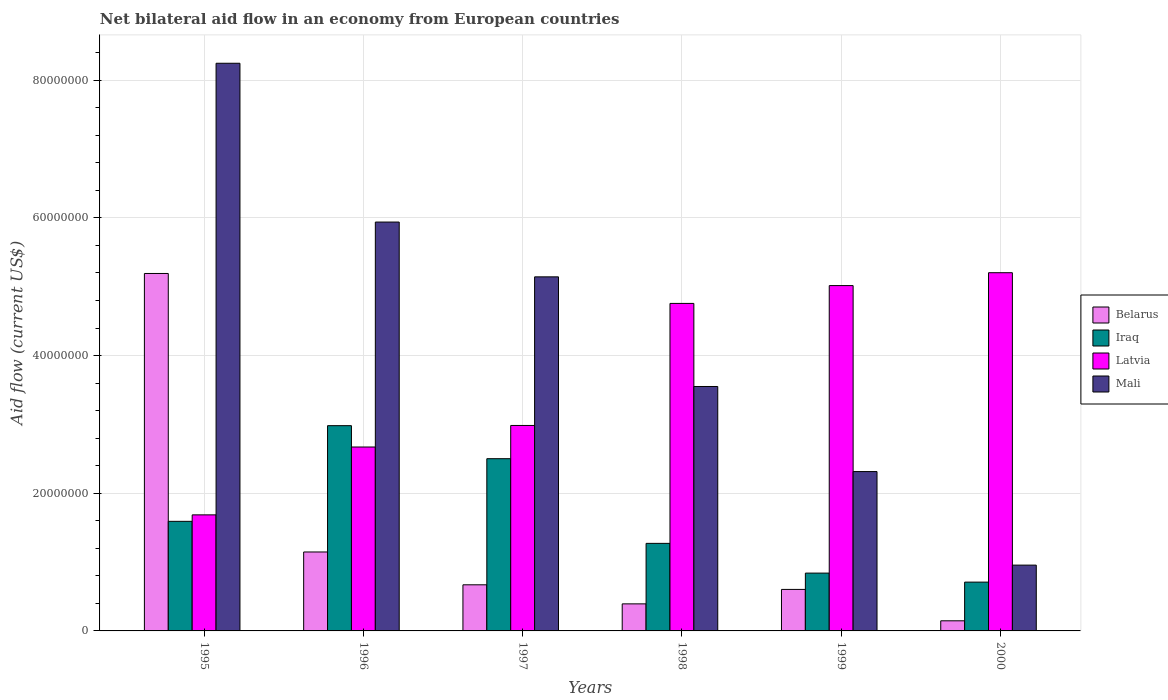How many different coloured bars are there?
Keep it short and to the point. 4. How many groups of bars are there?
Give a very brief answer. 6. Are the number of bars on each tick of the X-axis equal?
Offer a terse response. Yes. How many bars are there on the 5th tick from the right?
Your response must be concise. 4. What is the label of the 3rd group of bars from the left?
Offer a very short reply. 1997. In how many cases, is the number of bars for a given year not equal to the number of legend labels?
Offer a very short reply. 0. What is the net bilateral aid flow in Mali in 2000?
Provide a succinct answer. 9.56e+06. Across all years, what is the maximum net bilateral aid flow in Belarus?
Your response must be concise. 5.19e+07. Across all years, what is the minimum net bilateral aid flow in Mali?
Your answer should be very brief. 9.56e+06. In which year was the net bilateral aid flow in Belarus maximum?
Offer a very short reply. 1995. In which year was the net bilateral aid flow in Latvia minimum?
Ensure brevity in your answer.  1995. What is the total net bilateral aid flow in Mali in the graph?
Give a very brief answer. 2.62e+08. What is the difference between the net bilateral aid flow in Iraq in 1995 and that in 1996?
Provide a succinct answer. -1.39e+07. What is the difference between the net bilateral aid flow in Iraq in 2000 and the net bilateral aid flow in Belarus in 1995?
Your response must be concise. -4.48e+07. What is the average net bilateral aid flow in Iraq per year?
Offer a very short reply. 1.65e+07. In the year 1996, what is the difference between the net bilateral aid flow in Belarus and net bilateral aid flow in Latvia?
Provide a succinct answer. -1.52e+07. What is the ratio of the net bilateral aid flow in Latvia in 1995 to that in 1997?
Offer a terse response. 0.56. Is the net bilateral aid flow in Belarus in 1997 less than that in 1998?
Keep it short and to the point. No. What is the difference between the highest and the second highest net bilateral aid flow in Latvia?
Give a very brief answer. 1.87e+06. What is the difference between the highest and the lowest net bilateral aid flow in Mali?
Offer a terse response. 7.29e+07. In how many years, is the net bilateral aid flow in Belarus greater than the average net bilateral aid flow in Belarus taken over all years?
Provide a succinct answer. 1. Is it the case that in every year, the sum of the net bilateral aid flow in Iraq and net bilateral aid flow in Latvia is greater than the sum of net bilateral aid flow in Mali and net bilateral aid flow in Belarus?
Make the answer very short. No. What does the 2nd bar from the left in 1995 represents?
Make the answer very short. Iraq. What does the 2nd bar from the right in 1999 represents?
Offer a terse response. Latvia. Are all the bars in the graph horizontal?
Your answer should be very brief. No. Are the values on the major ticks of Y-axis written in scientific E-notation?
Your response must be concise. No. How many legend labels are there?
Make the answer very short. 4. What is the title of the graph?
Provide a succinct answer. Net bilateral aid flow in an economy from European countries. Does "Bermuda" appear as one of the legend labels in the graph?
Your answer should be compact. No. What is the label or title of the X-axis?
Offer a terse response. Years. What is the Aid flow (current US$) of Belarus in 1995?
Your answer should be very brief. 5.19e+07. What is the Aid flow (current US$) of Iraq in 1995?
Offer a very short reply. 1.59e+07. What is the Aid flow (current US$) of Latvia in 1995?
Offer a very short reply. 1.69e+07. What is the Aid flow (current US$) of Mali in 1995?
Offer a very short reply. 8.25e+07. What is the Aid flow (current US$) in Belarus in 1996?
Provide a short and direct response. 1.15e+07. What is the Aid flow (current US$) of Iraq in 1996?
Give a very brief answer. 2.98e+07. What is the Aid flow (current US$) in Latvia in 1996?
Provide a succinct answer. 2.67e+07. What is the Aid flow (current US$) in Mali in 1996?
Ensure brevity in your answer.  5.94e+07. What is the Aid flow (current US$) in Belarus in 1997?
Keep it short and to the point. 6.70e+06. What is the Aid flow (current US$) in Iraq in 1997?
Your answer should be very brief. 2.50e+07. What is the Aid flow (current US$) in Latvia in 1997?
Your response must be concise. 2.98e+07. What is the Aid flow (current US$) of Mali in 1997?
Ensure brevity in your answer.  5.14e+07. What is the Aid flow (current US$) in Belarus in 1998?
Ensure brevity in your answer.  3.93e+06. What is the Aid flow (current US$) of Iraq in 1998?
Offer a terse response. 1.27e+07. What is the Aid flow (current US$) in Latvia in 1998?
Offer a terse response. 4.76e+07. What is the Aid flow (current US$) in Mali in 1998?
Ensure brevity in your answer.  3.55e+07. What is the Aid flow (current US$) in Belarus in 1999?
Make the answer very short. 6.03e+06. What is the Aid flow (current US$) of Iraq in 1999?
Ensure brevity in your answer.  8.40e+06. What is the Aid flow (current US$) in Latvia in 1999?
Make the answer very short. 5.02e+07. What is the Aid flow (current US$) of Mali in 1999?
Your answer should be compact. 2.32e+07. What is the Aid flow (current US$) of Belarus in 2000?
Make the answer very short. 1.47e+06. What is the Aid flow (current US$) of Iraq in 2000?
Offer a very short reply. 7.09e+06. What is the Aid flow (current US$) of Latvia in 2000?
Make the answer very short. 5.20e+07. What is the Aid flow (current US$) in Mali in 2000?
Offer a very short reply. 9.56e+06. Across all years, what is the maximum Aid flow (current US$) of Belarus?
Provide a succinct answer. 5.19e+07. Across all years, what is the maximum Aid flow (current US$) of Iraq?
Offer a very short reply. 2.98e+07. Across all years, what is the maximum Aid flow (current US$) of Latvia?
Your answer should be very brief. 5.20e+07. Across all years, what is the maximum Aid flow (current US$) in Mali?
Provide a succinct answer. 8.25e+07. Across all years, what is the minimum Aid flow (current US$) of Belarus?
Make the answer very short. 1.47e+06. Across all years, what is the minimum Aid flow (current US$) of Iraq?
Ensure brevity in your answer.  7.09e+06. Across all years, what is the minimum Aid flow (current US$) in Latvia?
Offer a terse response. 1.69e+07. Across all years, what is the minimum Aid flow (current US$) in Mali?
Offer a very short reply. 9.56e+06. What is the total Aid flow (current US$) in Belarus in the graph?
Your answer should be compact. 8.15e+07. What is the total Aid flow (current US$) of Iraq in the graph?
Give a very brief answer. 9.90e+07. What is the total Aid flow (current US$) in Latvia in the graph?
Keep it short and to the point. 2.23e+08. What is the total Aid flow (current US$) in Mali in the graph?
Provide a short and direct response. 2.62e+08. What is the difference between the Aid flow (current US$) of Belarus in 1995 and that in 1996?
Your answer should be very brief. 4.05e+07. What is the difference between the Aid flow (current US$) in Iraq in 1995 and that in 1996?
Offer a very short reply. -1.39e+07. What is the difference between the Aid flow (current US$) in Latvia in 1995 and that in 1996?
Your response must be concise. -9.86e+06. What is the difference between the Aid flow (current US$) of Mali in 1995 and that in 1996?
Provide a succinct answer. 2.31e+07. What is the difference between the Aid flow (current US$) of Belarus in 1995 and that in 1997?
Your answer should be very brief. 4.52e+07. What is the difference between the Aid flow (current US$) of Iraq in 1995 and that in 1997?
Offer a terse response. -9.10e+06. What is the difference between the Aid flow (current US$) of Latvia in 1995 and that in 1997?
Your response must be concise. -1.30e+07. What is the difference between the Aid flow (current US$) of Mali in 1995 and that in 1997?
Make the answer very short. 3.10e+07. What is the difference between the Aid flow (current US$) in Belarus in 1995 and that in 1998?
Your answer should be compact. 4.80e+07. What is the difference between the Aid flow (current US$) of Iraq in 1995 and that in 1998?
Offer a terse response. 3.20e+06. What is the difference between the Aid flow (current US$) of Latvia in 1995 and that in 1998?
Provide a short and direct response. -3.07e+07. What is the difference between the Aid flow (current US$) of Mali in 1995 and that in 1998?
Ensure brevity in your answer.  4.70e+07. What is the difference between the Aid flow (current US$) in Belarus in 1995 and that in 1999?
Your answer should be compact. 4.59e+07. What is the difference between the Aid flow (current US$) in Iraq in 1995 and that in 1999?
Ensure brevity in your answer.  7.52e+06. What is the difference between the Aid flow (current US$) in Latvia in 1995 and that in 1999?
Ensure brevity in your answer.  -3.33e+07. What is the difference between the Aid flow (current US$) in Mali in 1995 and that in 1999?
Give a very brief answer. 5.93e+07. What is the difference between the Aid flow (current US$) in Belarus in 1995 and that in 2000?
Provide a succinct answer. 5.05e+07. What is the difference between the Aid flow (current US$) in Iraq in 1995 and that in 2000?
Keep it short and to the point. 8.83e+06. What is the difference between the Aid flow (current US$) of Latvia in 1995 and that in 2000?
Your answer should be compact. -3.52e+07. What is the difference between the Aid flow (current US$) in Mali in 1995 and that in 2000?
Ensure brevity in your answer.  7.29e+07. What is the difference between the Aid flow (current US$) in Belarus in 1996 and that in 1997?
Provide a short and direct response. 4.77e+06. What is the difference between the Aid flow (current US$) of Iraq in 1996 and that in 1997?
Make the answer very short. 4.80e+06. What is the difference between the Aid flow (current US$) of Latvia in 1996 and that in 1997?
Ensure brevity in your answer.  -3.13e+06. What is the difference between the Aid flow (current US$) in Mali in 1996 and that in 1997?
Ensure brevity in your answer.  7.96e+06. What is the difference between the Aid flow (current US$) in Belarus in 1996 and that in 1998?
Offer a terse response. 7.54e+06. What is the difference between the Aid flow (current US$) of Iraq in 1996 and that in 1998?
Your answer should be compact. 1.71e+07. What is the difference between the Aid flow (current US$) in Latvia in 1996 and that in 1998?
Your response must be concise. -2.09e+07. What is the difference between the Aid flow (current US$) of Mali in 1996 and that in 1998?
Keep it short and to the point. 2.39e+07. What is the difference between the Aid flow (current US$) in Belarus in 1996 and that in 1999?
Make the answer very short. 5.44e+06. What is the difference between the Aid flow (current US$) in Iraq in 1996 and that in 1999?
Keep it short and to the point. 2.14e+07. What is the difference between the Aid flow (current US$) of Latvia in 1996 and that in 1999?
Ensure brevity in your answer.  -2.34e+07. What is the difference between the Aid flow (current US$) in Mali in 1996 and that in 1999?
Offer a terse response. 3.62e+07. What is the difference between the Aid flow (current US$) in Iraq in 1996 and that in 2000?
Keep it short and to the point. 2.27e+07. What is the difference between the Aid flow (current US$) in Latvia in 1996 and that in 2000?
Offer a very short reply. -2.53e+07. What is the difference between the Aid flow (current US$) in Mali in 1996 and that in 2000?
Your answer should be compact. 4.98e+07. What is the difference between the Aid flow (current US$) of Belarus in 1997 and that in 1998?
Your answer should be compact. 2.77e+06. What is the difference between the Aid flow (current US$) in Iraq in 1997 and that in 1998?
Give a very brief answer. 1.23e+07. What is the difference between the Aid flow (current US$) in Latvia in 1997 and that in 1998?
Your answer should be compact. -1.77e+07. What is the difference between the Aid flow (current US$) in Mali in 1997 and that in 1998?
Keep it short and to the point. 1.59e+07. What is the difference between the Aid flow (current US$) in Belarus in 1997 and that in 1999?
Offer a very short reply. 6.70e+05. What is the difference between the Aid flow (current US$) of Iraq in 1997 and that in 1999?
Offer a terse response. 1.66e+07. What is the difference between the Aid flow (current US$) in Latvia in 1997 and that in 1999?
Provide a short and direct response. -2.03e+07. What is the difference between the Aid flow (current US$) in Mali in 1997 and that in 1999?
Offer a terse response. 2.83e+07. What is the difference between the Aid flow (current US$) of Belarus in 1997 and that in 2000?
Give a very brief answer. 5.23e+06. What is the difference between the Aid flow (current US$) in Iraq in 1997 and that in 2000?
Keep it short and to the point. 1.79e+07. What is the difference between the Aid flow (current US$) of Latvia in 1997 and that in 2000?
Give a very brief answer. -2.22e+07. What is the difference between the Aid flow (current US$) in Mali in 1997 and that in 2000?
Give a very brief answer. 4.19e+07. What is the difference between the Aid flow (current US$) in Belarus in 1998 and that in 1999?
Make the answer very short. -2.10e+06. What is the difference between the Aid flow (current US$) of Iraq in 1998 and that in 1999?
Offer a terse response. 4.32e+06. What is the difference between the Aid flow (current US$) of Latvia in 1998 and that in 1999?
Give a very brief answer. -2.59e+06. What is the difference between the Aid flow (current US$) of Mali in 1998 and that in 1999?
Provide a succinct answer. 1.24e+07. What is the difference between the Aid flow (current US$) in Belarus in 1998 and that in 2000?
Offer a very short reply. 2.46e+06. What is the difference between the Aid flow (current US$) in Iraq in 1998 and that in 2000?
Your answer should be compact. 5.63e+06. What is the difference between the Aid flow (current US$) in Latvia in 1998 and that in 2000?
Provide a succinct answer. -4.46e+06. What is the difference between the Aid flow (current US$) of Mali in 1998 and that in 2000?
Ensure brevity in your answer.  2.60e+07. What is the difference between the Aid flow (current US$) of Belarus in 1999 and that in 2000?
Your answer should be very brief. 4.56e+06. What is the difference between the Aid flow (current US$) of Iraq in 1999 and that in 2000?
Your response must be concise. 1.31e+06. What is the difference between the Aid flow (current US$) in Latvia in 1999 and that in 2000?
Keep it short and to the point. -1.87e+06. What is the difference between the Aid flow (current US$) of Mali in 1999 and that in 2000?
Ensure brevity in your answer.  1.36e+07. What is the difference between the Aid flow (current US$) of Belarus in 1995 and the Aid flow (current US$) of Iraq in 1996?
Provide a succinct answer. 2.21e+07. What is the difference between the Aid flow (current US$) in Belarus in 1995 and the Aid flow (current US$) in Latvia in 1996?
Ensure brevity in your answer.  2.52e+07. What is the difference between the Aid flow (current US$) in Belarus in 1995 and the Aid flow (current US$) in Mali in 1996?
Give a very brief answer. -7.47e+06. What is the difference between the Aid flow (current US$) in Iraq in 1995 and the Aid flow (current US$) in Latvia in 1996?
Provide a short and direct response. -1.08e+07. What is the difference between the Aid flow (current US$) of Iraq in 1995 and the Aid flow (current US$) of Mali in 1996?
Give a very brief answer. -4.35e+07. What is the difference between the Aid flow (current US$) in Latvia in 1995 and the Aid flow (current US$) in Mali in 1996?
Offer a very short reply. -4.25e+07. What is the difference between the Aid flow (current US$) in Belarus in 1995 and the Aid flow (current US$) in Iraq in 1997?
Provide a succinct answer. 2.69e+07. What is the difference between the Aid flow (current US$) of Belarus in 1995 and the Aid flow (current US$) of Latvia in 1997?
Offer a very short reply. 2.21e+07. What is the difference between the Aid flow (current US$) in Belarus in 1995 and the Aid flow (current US$) in Mali in 1997?
Offer a very short reply. 4.90e+05. What is the difference between the Aid flow (current US$) in Iraq in 1995 and the Aid flow (current US$) in Latvia in 1997?
Provide a succinct answer. -1.39e+07. What is the difference between the Aid flow (current US$) in Iraq in 1995 and the Aid flow (current US$) in Mali in 1997?
Provide a succinct answer. -3.55e+07. What is the difference between the Aid flow (current US$) of Latvia in 1995 and the Aid flow (current US$) of Mali in 1997?
Keep it short and to the point. -3.46e+07. What is the difference between the Aid flow (current US$) of Belarus in 1995 and the Aid flow (current US$) of Iraq in 1998?
Ensure brevity in your answer.  3.92e+07. What is the difference between the Aid flow (current US$) in Belarus in 1995 and the Aid flow (current US$) in Latvia in 1998?
Keep it short and to the point. 4.35e+06. What is the difference between the Aid flow (current US$) in Belarus in 1995 and the Aid flow (current US$) in Mali in 1998?
Make the answer very short. 1.64e+07. What is the difference between the Aid flow (current US$) in Iraq in 1995 and the Aid flow (current US$) in Latvia in 1998?
Provide a short and direct response. -3.17e+07. What is the difference between the Aid flow (current US$) of Iraq in 1995 and the Aid flow (current US$) of Mali in 1998?
Your answer should be compact. -1.96e+07. What is the difference between the Aid flow (current US$) in Latvia in 1995 and the Aid flow (current US$) in Mali in 1998?
Your answer should be very brief. -1.86e+07. What is the difference between the Aid flow (current US$) of Belarus in 1995 and the Aid flow (current US$) of Iraq in 1999?
Your response must be concise. 4.35e+07. What is the difference between the Aid flow (current US$) in Belarus in 1995 and the Aid flow (current US$) in Latvia in 1999?
Your answer should be compact. 1.76e+06. What is the difference between the Aid flow (current US$) of Belarus in 1995 and the Aid flow (current US$) of Mali in 1999?
Your answer should be compact. 2.88e+07. What is the difference between the Aid flow (current US$) of Iraq in 1995 and the Aid flow (current US$) of Latvia in 1999?
Your response must be concise. -3.42e+07. What is the difference between the Aid flow (current US$) in Iraq in 1995 and the Aid flow (current US$) in Mali in 1999?
Your answer should be very brief. -7.23e+06. What is the difference between the Aid flow (current US$) in Latvia in 1995 and the Aid flow (current US$) in Mali in 1999?
Offer a very short reply. -6.29e+06. What is the difference between the Aid flow (current US$) in Belarus in 1995 and the Aid flow (current US$) in Iraq in 2000?
Keep it short and to the point. 4.48e+07. What is the difference between the Aid flow (current US$) of Belarus in 1995 and the Aid flow (current US$) of Latvia in 2000?
Provide a succinct answer. -1.10e+05. What is the difference between the Aid flow (current US$) of Belarus in 1995 and the Aid flow (current US$) of Mali in 2000?
Make the answer very short. 4.24e+07. What is the difference between the Aid flow (current US$) of Iraq in 1995 and the Aid flow (current US$) of Latvia in 2000?
Provide a succinct answer. -3.61e+07. What is the difference between the Aid flow (current US$) of Iraq in 1995 and the Aid flow (current US$) of Mali in 2000?
Provide a short and direct response. 6.36e+06. What is the difference between the Aid flow (current US$) of Latvia in 1995 and the Aid flow (current US$) of Mali in 2000?
Provide a succinct answer. 7.30e+06. What is the difference between the Aid flow (current US$) in Belarus in 1996 and the Aid flow (current US$) in Iraq in 1997?
Ensure brevity in your answer.  -1.36e+07. What is the difference between the Aid flow (current US$) of Belarus in 1996 and the Aid flow (current US$) of Latvia in 1997?
Your response must be concise. -1.84e+07. What is the difference between the Aid flow (current US$) of Belarus in 1996 and the Aid flow (current US$) of Mali in 1997?
Give a very brief answer. -4.00e+07. What is the difference between the Aid flow (current US$) of Iraq in 1996 and the Aid flow (current US$) of Latvia in 1997?
Keep it short and to the point. -3.00e+04. What is the difference between the Aid flow (current US$) in Iraq in 1996 and the Aid flow (current US$) in Mali in 1997?
Your response must be concise. -2.16e+07. What is the difference between the Aid flow (current US$) in Latvia in 1996 and the Aid flow (current US$) in Mali in 1997?
Make the answer very short. -2.47e+07. What is the difference between the Aid flow (current US$) in Belarus in 1996 and the Aid flow (current US$) in Iraq in 1998?
Offer a terse response. -1.25e+06. What is the difference between the Aid flow (current US$) in Belarus in 1996 and the Aid flow (current US$) in Latvia in 1998?
Make the answer very short. -3.61e+07. What is the difference between the Aid flow (current US$) of Belarus in 1996 and the Aid flow (current US$) of Mali in 1998?
Ensure brevity in your answer.  -2.40e+07. What is the difference between the Aid flow (current US$) in Iraq in 1996 and the Aid flow (current US$) in Latvia in 1998?
Your response must be concise. -1.78e+07. What is the difference between the Aid flow (current US$) in Iraq in 1996 and the Aid flow (current US$) in Mali in 1998?
Your answer should be compact. -5.69e+06. What is the difference between the Aid flow (current US$) of Latvia in 1996 and the Aid flow (current US$) of Mali in 1998?
Provide a succinct answer. -8.79e+06. What is the difference between the Aid flow (current US$) of Belarus in 1996 and the Aid flow (current US$) of Iraq in 1999?
Ensure brevity in your answer.  3.07e+06. What is the difference between the Aid flow (current US$) of Belarus in 1996 and the Aid flow (current US$) of Latvia in 1999?
Offer a very short reply. -3.87e+07. What is the difference between the Aid flow (current US$) of Belarus in 1996 and the Aid flow (current US$) of Mali in 1999?
Your answer should be very brief. -1.17e+07. What is the difference between the Aid flow (current US$) of Iraq in 1996 and the Aid flow (current US$) of Latvia in 1999?
Ensure brevity in your answer.  -2.04e+07. What is the difference between the Aid flow (current US$) in Iraq in 1996 and the Aid flow (current US$) in Mali in 1999?
Provide a short and direct response. 6.67e+06. What is the difference between the Aid flow (current US$) in Latvia in 1996 and the Aid flow (current US$) in Mali in 1999?
Your answer should be compact. 3.57e+06. What is the difference between the Aid flow (current US$) in Belarus in 1996 and the Aid flow (current US$) in Iraq in 2000?
Your response must be concise. 4.38e+06. What is the difference between the Aid flow (current US$) in Belarus in 1996 and the Aid flow (current US$) in Latvia in 2000?
Provide a short and direct response. -4.06e+07. What is the difference between the Aid flow (current US$) of Belarus in 1996 and the Aid flow (current US$) of Mali in 2000?
Offer a terse response. 1.91e+06. What is the difference between the Aid flow (current US$) of Iraq in 1996 and the Aid flow (current US$) of Latvia in 2000?
Provide a succinct answer. -2.22e+07. What is the difference between the Aid flow (current US$) in Iraq in 1996 and the Aid flow (current US$) in Mali in 2000?
Your answer should be very brief. 2.03e+07. What is the difference between the Aid flow (current US$) of Latvia in 1996 and the Aid flow (current US$) of Mali in 2000?
Make the answer very short. 1.72e+07. What is the difference between the Aid flow (current US$) of Belarus in 1997 and the Aid flow (current US$) of Iraq in 1998?
Make the answer very short. -6.02e+06. What is the difference between the Aid flow (current US$) of Belarus in 1997 and the Aid flow (current US$) of Latvia in 1998?
Give a very brief answer. -4.09e+07. What is the difference between the Aid flow (current US$) in Belarus in 1997 and the Aid flow (current US$) in Mali in 1998?
Offer a terse response. -2.88e+07. What is the difference between the Aid flow (current US$) of Iraq in 1997 and the Aid flow (current US$) of Latvia in 1998?
Make the answer very short. -2.26e+07. What is the difference between the Aid flow (current US$) in Iraq in 1997 and the Aid flow (current US$) in Mali in 1998?
Make the answer very short. -1.05e+07. What is the difference between the Aid flow (current US$) in Latvia in 1997 and the Aid flow (current US$) in Mali in 1998?
Your response must be concise. -5.66e+06. What is the difference between the Aid flow (current US$) in Belarus in 1997 and the Aid flow (current US$) in Iraq in 1999?
Provide a succinct answer. -1.70e+06. What is the difference between the Aid flow (current US$) in Belarus in 1997 and the Aid flow (current US$) in Latvia in 1999?
Your answer should be very brief. -4.35e+07. What is the difference between the Aid flow (current US$) of Belarus in 1997 and the Aid flow (current US$) of Mali in 1999?
Provide a short and direct response. -1.64e+07. What is the difference between the Aid flow (current US$) in Iraq in 1997 and the Aid flow (current US$) in Latvia in 1999?
Your response must be concise. -2.52e+07. What is the difference between the Aid flow (current US$) of Iraq in 1997 and the Aid flow (current US$) of Mali in 1999?
Your response must be concise. 1.87e+06. What is the difference between the Aid flow (current US$) in Latvia in 1997 and the Aid flow (current US$) in Mali in 1999?
Offer a very short reply. 6.70e+06. What is the difference between the Aid flow (current US$) of Belarus in 1997 and the Aid flow (current US$) of Iraq in 2000?
Provide a short and direct response. -3.90e+05. What is the difference between the Aid flow (current US$) in Belarus in 1997 and the Aid flow (current US$) in Latvia in 2000?
Your response must be concise. -4.53e+07. What is the difference between the Aid flow (current US$) of Belarus in 1997 and the Aid flow (current US$) of Mali in 2000?
Your answer should be compact. -2.86e+06. What is the difference between the Aid flow (current US$) of Iraq in 1997 and the Aid flow (current US$) of Latvia in 2000?
Give a very brief answer. -2.70e+07. What is the difference between the Aid flow (current US$) in Iraq in 1997 and the Aid flow (current US$) in Mali in 2000?
Provide a succinct answer. 1.55e+07. What is the difference between the Aid flow (current US$) of Latvia in 1997 and the Aid flow (current US$) of Mali in 2000?
Provide a succinct answer. 2.03e+07. What is the difference between the Aid flow (current US$) of Belarus in 1998 and the Aid flow (current US$) of Iraq in 1999?
Ensure brevity in your answer.  -4.47e+06. What is the difference between the Aid flow (current US$) of Belarus in 1998 and the Aid flow (current US$) of Latvia in 1999?
Ensure brevity in your answer.  -4.62e+07. What is the difference between the Aid flow (current US$) of Belarus in 1998 and the Aid flow (current US$) of Mali in 1999?
Make the answer very short. -1.92e+07. What is the difference between the Aid flow (current US$) of Iraq in 1998 and the Aid flow (current US$) of Latvia in 1999?
Give a very brief answer. -3.74e+07. What is the difference between the Aid flow (current US$) in Iraq in 1998 and the Aid flow (current US$) in Mali in 1999?
Keep it short and to the point. -1.04e+07. What is the difference between the Aid flow (current US$) in Latvia in 1998 and the Aid flow (current US$) in Mali in 1999?
Keep it short and to the point. 2.44e+07. What is the difference between the Aid flow (current US$) of Belarus in 1998 and the Aid flow (current US$) of Iraq in 2000?
Ensure brevity in your answer.  -3.16e+06. What is the difference between the Aid flow (current US$) of Belarus in 1998 and the Aid flow (current US$) of Latvia in 2000?
Your response must be concise. -4.81e+07. What is the difference between the Aid flow (current US$) of Belarus in 1998 and the Aid flow (current US$) of Mali in 2000?
Provide a short and direct response. -5.63e+06. What is the difference between the Aid flow (current US$) in Iraq in 1998 and the Aid flow (current US$) in Latvia in 2000?
Your response must be concise. -3.93e+07. What is the difference between the Aid flow (current US$) of Iraq in 1998 and the Aid flow (current US$) of Mali in 2000?
Give a very brief answer. 3.16e+06. What is the difference between the Aid flow (current US$) in Latvia in 1998 and the Aid flow (current US$) in Mali in 2000?
Give a very brief answer. 3.80e+07. What is the difference between the Aid flow (current US$) of Belarus in 1999 and the Aid flow (current US$) of Iraq in 2000?
Make the answer very short. -1.06e+06. What is the difference between the Aid flow (current US$) of Belarus in 1999 and the Aid flow (current US$) of Latvia in 2000?
Provide a short and direct response. -4.60e+07. What is the difference between the Aid flow (current US$) in Belarus in 1999 and the Aid flow (current US$) in Mali in 2000?
Give a very brief answer. -3.53e+06. What is the difference between the Aid flow (current US$) in Iraq in 1999 and the Aid flow (current US$) in Latvia in 2000?
Make the answer very short. -4.36e+07. What is the difference between the Aid flow (current US$) of Iraq in 1999 and the Aid flow (current US$) of Mali in 2000?
Offer a very short reply. -1.16e+06. What is the difference between the Aid flow (current US$) of Latvia in 1999 and the Aid flow (current US$) of Mali in 2000?
Ensure brevity in your answer.  4.06e+07. What is the average Aid flow (current US$) of Belarus per year?
Ensure brevity in your answer.  1.36e+07. What is the average Aid flow (current US$) in Iraq per year?
Keep it short and to the point. 1.65e+07. What is the average Aid flow (current US$) of Latvia per year?
Give a very brief answer. 3.72e+07. What is the average Aid flow (current US$) of Mali per year?
Offer a very short reply. 4.36e+07. In the year 1995, what is the difference between the Aid flow (current US$) of Belarus and Aid flow (current US$) of Iraq?
Give a very brief answer. 3.60e+07. In the year 1995, what is the difference between the Aid flow (current US$) in Belarus and Aid flow (current US$) in Latvia?
Make the answer very short. 3.51e+07. In the year 1995, what is the difference between the Aid flow (current US$) in Belarus and Aid flow (current US$) in Mali?
Make the answer very short. -3.05e+07. In the year 1995, what is the difference between the Aid flow (current US$) in Iraq and Aid flow (current US$) in Latvia?
Give a very brief answer. -9.40e+05. In the year 1995, what is the difference between the Aid flow (current US$) in Iraq and Aid flow (current US$) in Mali?
Your answer should be very brief. -6.66e+07. In the year 1995, what is the difference between the Aid flow (current US$) of Latvia and Aid flow (current US$) of Mali?
Provide a succinct answer. -6.56e+07. In the year 1996, what is the difference between the Aid flow (current US$) of Belarus and Aid flow (current US$) of Iraq?
Make the answer very short. -1.84e+07. In the year 1996, what is the difference between the Aid flow (current US$) in Belarus and Aid flow (current US$) in Latvia?
Offer a very short reply. -1.52e+07. In the year 1996, what is the difference between the Aid flow (current US$) of Belarus and Aid flow (current US$) of Mali?
Give a very brief answer. -4.79e+07. In the year 1996, what is the difference between the Aid flow (current US$) of Iraq and Aid flow (current US$) of Latvia?
Provide a short and direct response. 3.10e+06. In the year 1996, what is the difference between the Aid flow (current US$) of Iraq and Aid flow (current US$) of Mali?
Your response must be concise. -2.96e+07. In the year 1996, what is the difference between the Aid flow (current US$) in Latvia and Aid flow (current US$) in Mali?
Make the answer very short. -3.27e+07. In the year 1997, what is the difference between the Aid flow (current US$) in Belarus and Aid flow (current US$) in Iraq?
Ensure brevity in your answer.  -1.83e+07. In the year 1997, what is the difference between the Aid flow (current US$) of Belarus and Aid flow (current US$) of Latvia?
Offer a very short reply. -2.32e+07. In the year 1997, what is the difference between the Aid flow (current US$) in Belarus and Aid flow (current US$) in Mali?
Your answer should be very brief. -4.47e+07. In the year 1997, what is the difference between the Aid flow (current US$) of Iraq and Aid flow (current US$) of Latvia?
Your answer should be compact. -4.83e+06. In the year 1997, what is the difference between the Aid flow (current US$) of Iraq and Aid flow (current US$) of Mali?
Provide a short and direct response. -2.64e+07. In the year 1997, what is the difference between the Aid flow (current US$) in Latvia and Aid flow (current US$) in Mali?
Make the answer very short. -2.16e+07. In the year 1998, what is the difference between the Aid flow (current US$) of Belarus and Aid flow (current US$) of Iraq?
Offer a very short reply. -8.79e+06. In the year 1998, what is the difference between the Aid flow (current US$) in Belarus and Aid flow (current US$) in Latvia?
Ensure brevity in your answer.  -4.36e+07. In the year 1998, what is the difference between the Aid flow (current US$) in Belarus and Aid flow (current US$) in Mali?
Provide a succinct answer. -3.16e+07. In the year 1998, what is the difference between the Aid flow (current US$) in Iraq and Aid flow (current US$) in Latvia?
Offer a terse response. -3.49e+07. In the year 1998, what is the difference between the Aid flow (current US$) in Iraq and Aid flow (current US$) in Mali?
Offer a terse response. -2.28e+07. In the year 1998, what is the difference between the Aid flow (current US$) of Latvia and Aid flow (current US$) of Mali?
Ensure brevity in your answer.  1.21e+07. In the year 1999, what is the difference between the Aid flow (current US$) of Belarus and Aid flow (current US$) of Iraq?
Provide a succinct answer. -2.37e+06. In the year 1999, what is the difference between the Aid flow (current US$) in Belarus and Aid flow (current US$) in Latvia?
Offer a very short reply. -4.41e+07. In the year 1999, what is the difference between the Aid flow (current US$) of Belarus and Aid flow (current US$) of Mali?
Your answer should be very brief. -1.71e+07. In the year 1999, what is the difference between the Aid flow (current US$) of Iraq and Aid flow (current US$) of Latvia?
Ensure brevity in your answer.  -4.18e+07. In the year 1999, what is the difference between the Aid flow (current US$) of Iraq and Aid flow (current US$) of Mali?
Offer a terse response. -1.48e+07. In the year 1999, what is the difference between the Aid flow (current US$) of Latvia and Aid flow (current US$) of Mali?
Your answer should be very brief. 2.70e+07. In the year 2000, what is the difference between the Aid flow (current US$) in Belarus and Aid flow (current US$) in Iraq?
Your response must be concise. -5.62e+06. In the year 2000, what is the difference between the Aid flow (current US$) of Belarus and Aid flow (current US$) of Latvia?
Offer a very short reply. -5.06e+07. In the year 2000, what is the difference between the Aid flow (current US$) in Belarus and Aid flow (current US$) in Mali?
Your answer should be very brief. -8.09e+06. In the year 2000, what is the difference between the Aid flow (current US$) in Iraq and Aid flow (current US$) in Latvia?
Give a very brief answer. -4.50e+07. In the year 2000, what is the difference between the Aid flow (current US$) in Iraq and Aid flow (current US$) in Mali?
Offer a very short reply. -2.47e+06. In the year 2000, what is the difference between the Aid flow (current US$) in Latvia and Aid flow (current US$) in Mali?
Offer a terse response. 4.25e+07. What is the ratio of the Aid flow (current US$) in Belarus in 1995 to that in 1996?
Ensure brevity in your answer.  4.53. What is the ratio of the Aid flow (current US$) of Iraq in 1995 to that in 1996?
Provide a succinct answer. 0.53. What is the ratio of the Aid flow (current US$) of Latvia in 1995 to that in 1996?
Provide a short and direct response. 0.63. What is the ratio of the Aid flow (current US$) of Mali in 1995 to that in 1996?
Make the answer very short. 1.39. What is the ratio of the Aid flow (current US$) in Belarus in 1995 to that in 1997?
Give a very brief answer. 7.75. What is the ratio of the Aid flow (current US$) in Iraq in 1995 to that in 1997?
Your response must be concise. 0.64. What is the ratio of the Aid flow (current US$) in Latvia in 1995 to that in 1997?
Make the answer very short. 0.56. What is the ratio of the Aid flow (current US$) in Mali in 1995 to that in 1997?
Ensure brevity in your answer.  1.6. What is the ratio of the Aid flow (current US$) of Belarus in 1995 to that in 1998?
Provide a succinct answer. 13.21. What is the ratio of the Aid flow (current US$) in Iraq in 1995 to that in 1998?
Ensure brevity in your answer.  1.25. What is the ratio of the Aid flow (current US$) in Latvia in 1995 to that in 1998?
Make the answer very short. 0.35. What is the ratio of the Aid flow (current US$) of Mali in 1995 to that in 1998?
Provide a short and direct response. 2.32. What is the ratio of the Aid flow (current US$) of Belarus in 1995 to that in 1999?
Provide a short and direct response. 8.61. What is the ratio of the Aid flow (current US$) of Iraq in 1995 to that in 1999?
Give a very brief answer. 1.9. What is the ratio of the Aid flow (current US$) in Latvia in 1995 to that in 1999?
Offer a very short reply. 0.34. What is the ratio of the Aid flow (current US$) in Mali in 1995 to that in 1999?
Make the answer very short. 3.56. What is the ratio of the Aid flow (current US$) of Belarus in 1995 to that in 2000?
Keep it short and to the point. 35.33. What is the ratio of the Aid flow (current US$) of Iraq in 1995 to that in 2000?
Ensure brevity in your answer.  2.25. What is the ratio of the Aid flow (current US$) of Latvia in 1995 to that in 2000?
Provide a short and direct response. 0.32. What is the ratio of the Aid flow (current US$) of Mali in 1995 to that in 2000?
Provide a succinct answer. 8.63. What is the ratio of the Aid flow (current US$) in Belarus in 1996 to that in 1997?
Your response must be concise. 1.71. What is the ratio of the Aid flow (current US$) in Iraq in 1996 to that in 1997?
Make the answer very short. 1.19. What is the ratio of the Aid flow (current US$) of Latvia in 1996 to that in 1997?
Offer a very short reply. 0.9. What is the ratio of the Aid flow (current US$) in Mali in 1996 to that in 1997?
Your response must be concise. 1.15. What is the ratio of the Aid flow (current US$) in Belarus in 1996 to that in 1998?
Ensure brevity in your answer.  2.92. What is the ratio of the Aid flow (current US$) of Iraq in 1996 to that in 1998?
Offer a very short reply. 2.34. What is the ratio of the Aid flow (current US$) in Latvia in 1996 to that in 1998?
Provide a short and direct response. 0.56. What is the ratio of the Aid flow (current US$) of Mali in 1996 to that in 1998?
Ensure brevity in your answer.  1.67. What is the ratio of the Aid flow (current US$) of Belarus in 1996 to that in 1999?
Keep it short and to the point. 1.9. What is the ratio of the Aid flow (current US$) of Iraq in 1996 to that in 1999?
Make the answer very short. 3.55. What is the ratio of the Aid flow (current US$) of Latvia in 1996 to that in 1999?
Ensure brevity in your answer.  0.53. What is the ratio of the Aid flow (current US$) of Mali in 1996 to that in 1999?
Ensure brevity in your answer.  2.57. What is the ratio of the Aid flow (current US$) of Belarus in 1996 to that in 2000?
Make the answer very short. 7.8. What is the ratio of the Aid flow (current US$) in Iraq in 1996 to that in 2000?
Offer a terse response. 4.21. What is the ratio of the Aid flow (current US$) of Latvia in 1996 to that in 2000?
Provide a short and direct response. 0.51. What is the ratio of the Aid flow (current US$) in Mali in 1996 to that in 2000?
Ensure brevity in your answer.  6.21. What is the ratio of the Aid flow (current US$) in Belarus in 1997 to that in 1998?
Ensure brevity in your answer.  1.7. What is the ratio of the Aid flow (current US$) in Iraq in 1997 to that in 1998?
Make the answer very short. 1.97. What is the ratio of the Aid flow (current US$) in Latvia in 1997 to that in 1998?
Provide a succinct answer. 0.63. What is the ratio of the Aid flow (current US$) of Mali in 1997 to that in 1998?
Ensure brevity in your answer.  1.45. What is the ratio of the Aid flow (current US$) in Belarus in 1997 to that in 1999?
Keep it short and to the point. 1.11. What is the ratio of the Aid flow (current US$) in Iraq in 1997 to that in 1999?
Offer a terse response. 2.98. What is the ratio of the Aid flow (current US$) of Latvia in 1997 to that in 1999?
Keep it short and to the point. 0.59. What is the ratio of the Aid flow (current US$) of Mali in 1997 to that in 1999?
Your answer should be very brief. 2.22. What is the ratio of the Aid flow (current US$) of Belarus in 1997 to that in 2000?
Offer a terse response. 4.56. What is the ratio of the Aid flow (current US$) of Iraq in 1997 to that in 2000?
Your response must be concise. 3.53. What is the ratio of the Aid flow (current US$) in Latvia in 1997 to that in 2000?
Give a very brief answer. 0.57. What is the ratio of the Aid flow (current US$) of Mali in 1997 to that in 2000?
Give a very brief answer. 5.38. What is the ratio of the Aid flow (current US$) of Belarus in 1998 to that in 1999?
Keep it short and to the point. 0.65. What is the ratio of the Aid flow (current US$) of Iraq in 1998 to that in 1999?
Give a very brief answer. 1.51. What is the ratio of the Aid flow (current US$) in Latvia in 1998 to that in 1999?
Your answer should be compact. 0.95. What is the ratio of the Aid flow (current US$) of Mali in 1998 to that in 1999?
Ensure brevity in your answer.  1.53. What is the ratio of the Aid flow (current US$) of Belarus in 1998 to that in 2000?
Keep it short and to the point. 2.67. What is the ratio of the Aid flow (current US$) in Iraq in 1998 to that in 2000?
Your response must be concise. 1.79. What is the ratio of the Aid flow (current US$) in Latvia in 1998 to that in 2000?
Your answer should be very brief. 0.91. What is the ratio of the Aid flow (current US$) in Mali in 1998 to that in 2000?
Give a very brief answer. 3.71. What is the ratio of the Aid flow (current US$) of Belarus in 1999 to that in 2000?
Make the answer very short. 4.1. What is the ratio of the Aid flow (current US$) in Iraq in 1999 to that in 2000?
Provide a succinct answer. 1.18. What is the ratio of the Aid flow (current US$) of Latvia in 1999 to that in 2000?
Your answer should be compact. 0.96. What is the ratio of the Aid flow (current US$) in Mali in 1999 to that in 2000?
Provide a short and direct response. 2.42. What is the difference between the highest and the second highest Aid flow (current US$) of Belarus?
Offer a very short reply. 4.05e+07. What is the difference between the highest and the second highest Aid flow (current US$) in Iraq?
Ensure brevity in your answer.  4.80e+06. What is the difference between the highest and the second highest Aid flow (current US$) in Latvia?
Your answer should be very brief. 1.87e+06. What is the difference between the highest and the second highest Aid flow (current US$) in Mali?
Give a very brief answer. 2.31e+07. What is the difference between the highest and the lowest Aid flow (current US$) of Belarus?
Provide a short and direct response. 5.05e+07. What is the difference between the highest and the lowest Aid flow (current US$) in Iraq?
Ensure brevity in your answer.  2.27e+07. What is the difference between the highest and the lowest Aid flow (current US$) of Latvia?
Keep it short and to the point. 3.52e+07. What is the difference between the highest and the lowest Aid flow (current US$) of Mali?
Your answer should be compact. 7.29e+07. 